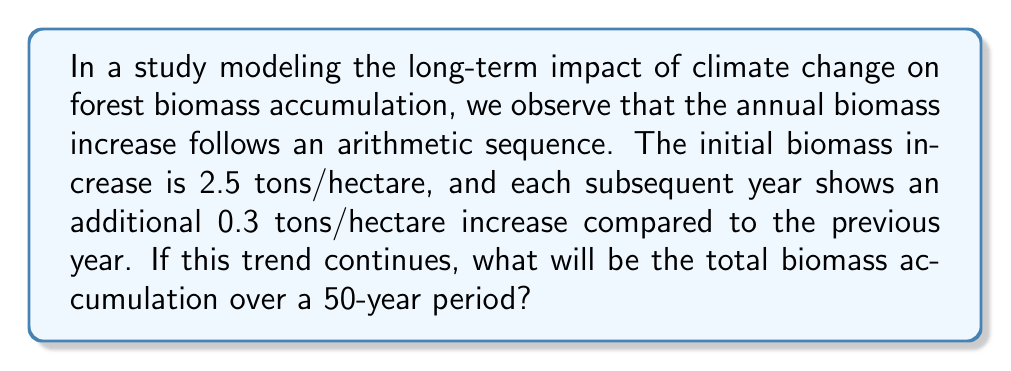What is the answer to this math problem? Let's approach this step-by-step:

1) We have an arithmetic sequence where:
   $a_1 = 2.5$ (first term)
   $d = 0.3$ (common difference)
   $n = 50$ (number of terms)

2) The last term of the sequence ($a_n$) can be calculated using:
   $a_n = a_1 + (n-1)d$
   $a_{50} = 2.5 + (50-1)(0.3) = 2.5 + 14.7 = 17.2$

3) For an arithmetic sequence, the sum of n terms is given by:
   $S_n = \frac{n}{2}(a_1 + a_n)$

4) Substituting our values:
   $S_{50} = \frac{50}{2}(2.5 + 17.2)$
   $S_{50} = 25(19.7)$
   $S_{50} = 492.5$

Therefore, the total biomass accumulation over 50 years will be 492.5 tons/hectare.
Answer: 492.5 tons/hectare 